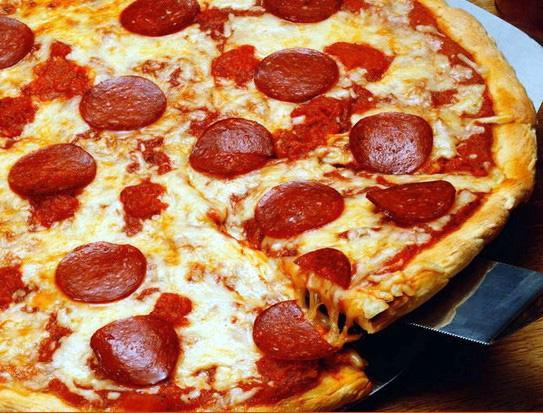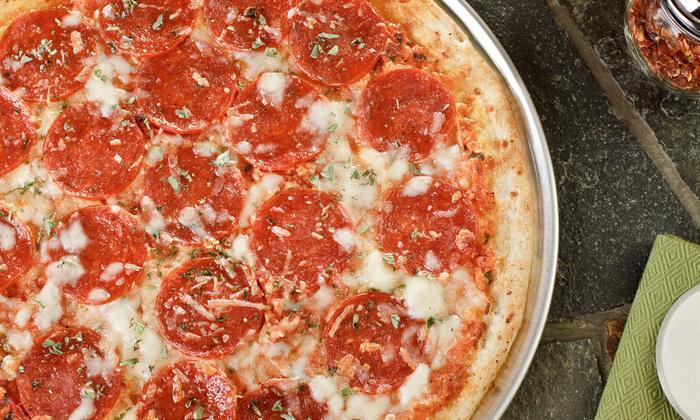The first image is the image on the left, the second image is the image on the right. For the images shown, is this caption "One pizza is pepperoni and the other has some green peppers." true? Answer yes or no. No. The first image is the image on the left, the second image is the image on the right. Considering the images on both sides, is "In one of the images there are tomatoes visible on the table." valid? Answer yes or no. No. 